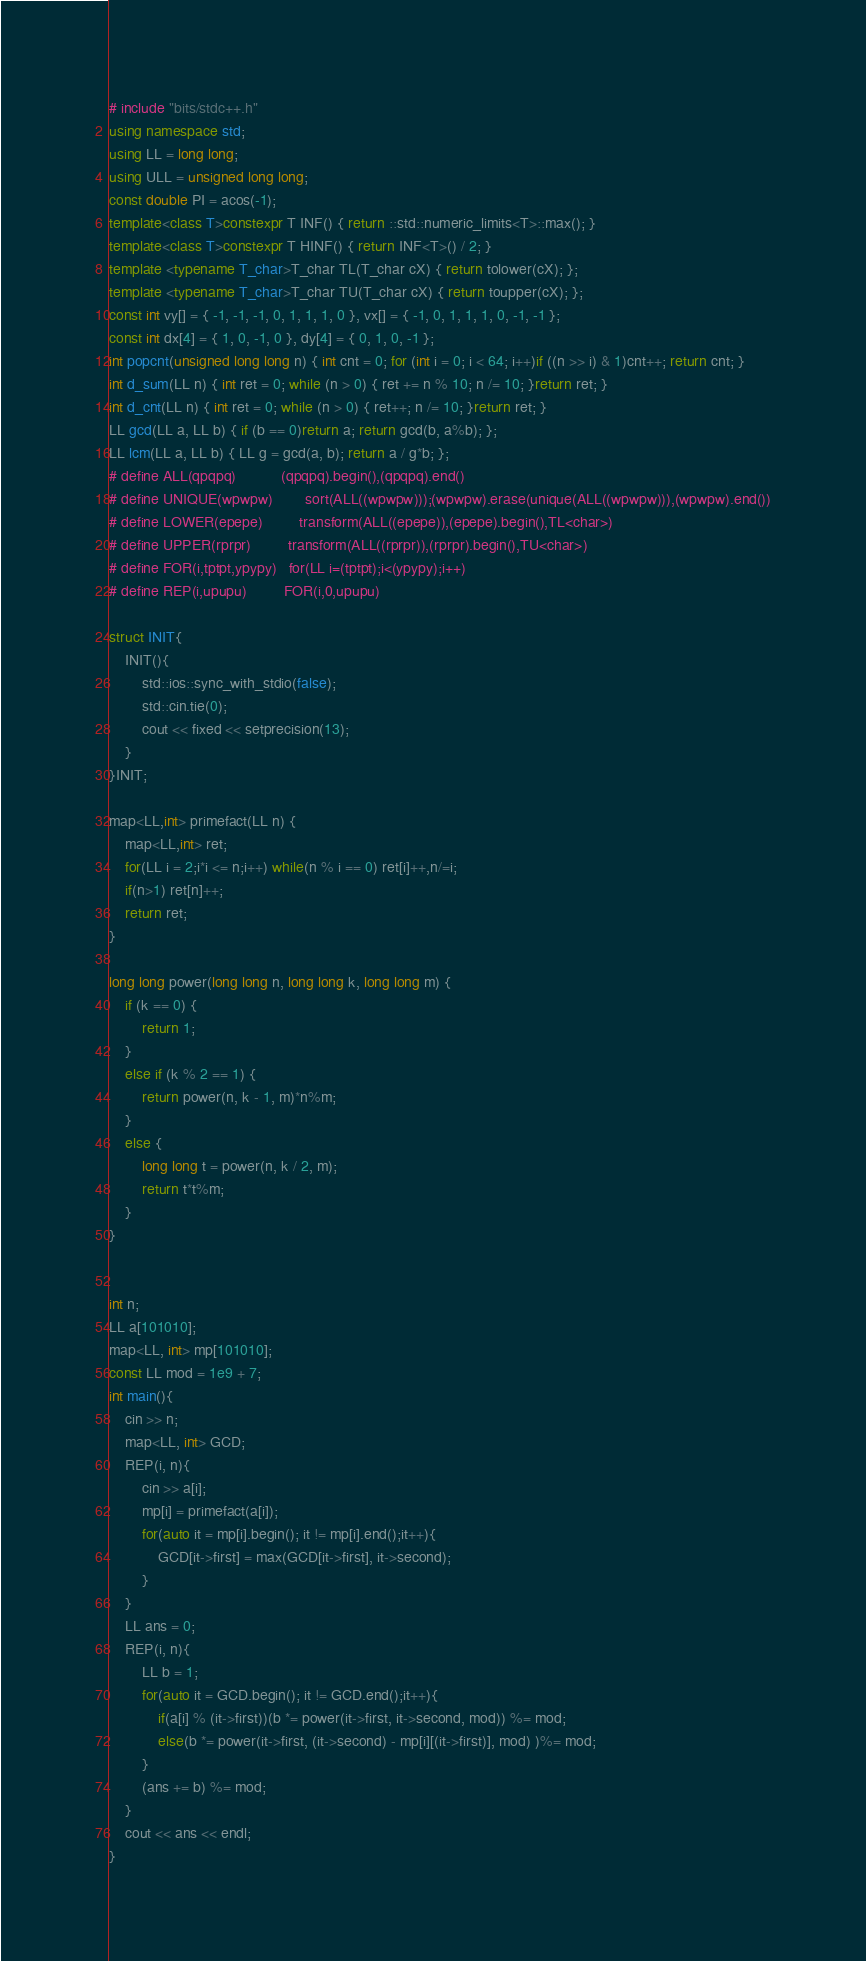Convert code to text. <code><loc_0><loc_0><loc_500><loc_500><_C++_># include "bits/stdc++.h"
using namespace std;
using LL = long long;
using ULL = unsigned long long;
const double PI = acos(-1);
template<class T>constexpr T INF() { return ::std::numeric_limits<T>::max(); }
template<class T>constexpr T HINF() { return INF<T>() / 2; }
template <typename T_char>T_char TL(T_char cX) { return tolower(cX); };
template <typename T_char>T_char TU(T_char cX) { return toupper(cX); };
const int vy[] = { -1, -1, -1, 0, 1, 1, 1, 0 }, vx[] = { -1, 0, 1, 1, 1, 0, -1, -1 };
const int dx[4] = { 1, 0, -1, 0 }, dy[4] = { 0, 1, 0, -1 };
int popcnt(unsigned long long n) { int cnt = 0; for (int i = 0; i < 64; i++)if ((n >> i) & 1)cnt++; return cnt; }
int d_sum(LL n) { int ret = 0; while (n > 0) { ret += n % 10; n /= 10; }return ret; }
int d_cnt(LL n) { int ret = 0; while (n > 0) { ret++; n /= 10; }return ret; }
LL gcd(LL a, LL b) { if (b == 0)return a; return gcd(b, a%b); };
LL lcm(LL a, LL b) { LL g = gcd(a, b); return a / g*b; };
# define ALL(qpqpq)           (qpqpq).begin(),(qpqpq).end()
# define UNIQUE(wpwpw)        sort(ALL((wpwpw)));(wpwpw).erase(unique(ALL((wpwpw))),(wpwpw).end())
# define LOWER(epepe)         transform(ALL((epepe)),(epepe).begin(),TL<char>)
# define UPPER(rprpr)         transform(ALL((rprpr)),(rprpr).begin(),TU<char>)
# define FOR(i,tptpt,ypypy)   for(LL i=(tptpt);i<(ypypy);i++)
# define REP(i,upupu)         FOR(i,0,upupu)

struct INIT{
    INIT(){
        std::ios::sync_with_stdio(false);
        std::cin.tie(0);
        cout << fixed << setprecision(13);
    }
}INIT;

map<LL,int> primefact(LL n) {
	map<LL,int> ret;
	for(LL i = 2;i*i <= n;i++) while(n % i == 0) ret[i]++,n/=i;
	if(n>1) ret[n]++;
	return ret;
}

long long power(long long n, long long k, long long m) {
	if (k == 0) {
		return 1;
	}
	else if (k % 2 == 1) {
		return power(n, k - 1, m)*n%m;
	}
	else {
		long long t = power(n, k / 2, m);
		return t*t%m;
	}
}


int n;
LL a[101010];
map<LL, int> mp[101010];
const LL mod = 1e9 + 7;
int main(){
    cin >> n;
    map<LL, int> GCD;
    REP(i, n){
        cin >> a[i];
        mp[i] = primefact(a[i]);
        for(auto it = mp[i].begin(); it != mp[i].end();it++){
            GCD[it->first] = max(GCD[it->first], it->second);
        }
    }
    LL ans = 0;
    REP(i, n){
        LL b = 1;
        for(auto it = GCD.begin(); it != GCD.end();it++){
            if(a[i] % (it->first))(b *= power(it->first, it->second, mod)) %= mod;
            else(b *= power(it->first, (it->second) - mp[i][(it->first)], mod) )%= mod;
        }
        (ans += b) %= mod;
    }
    cout << ans << endl;
}</code> 